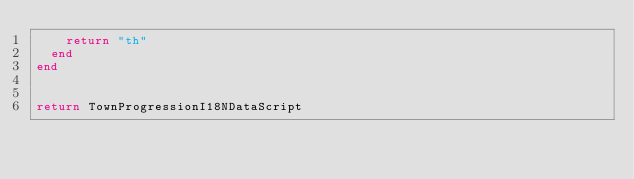<code> <loc_0><loc_0><loc_500><loc_500><_Lua_>    return "th"
  end
end


return TownProgressionI18NDataScript</code> 